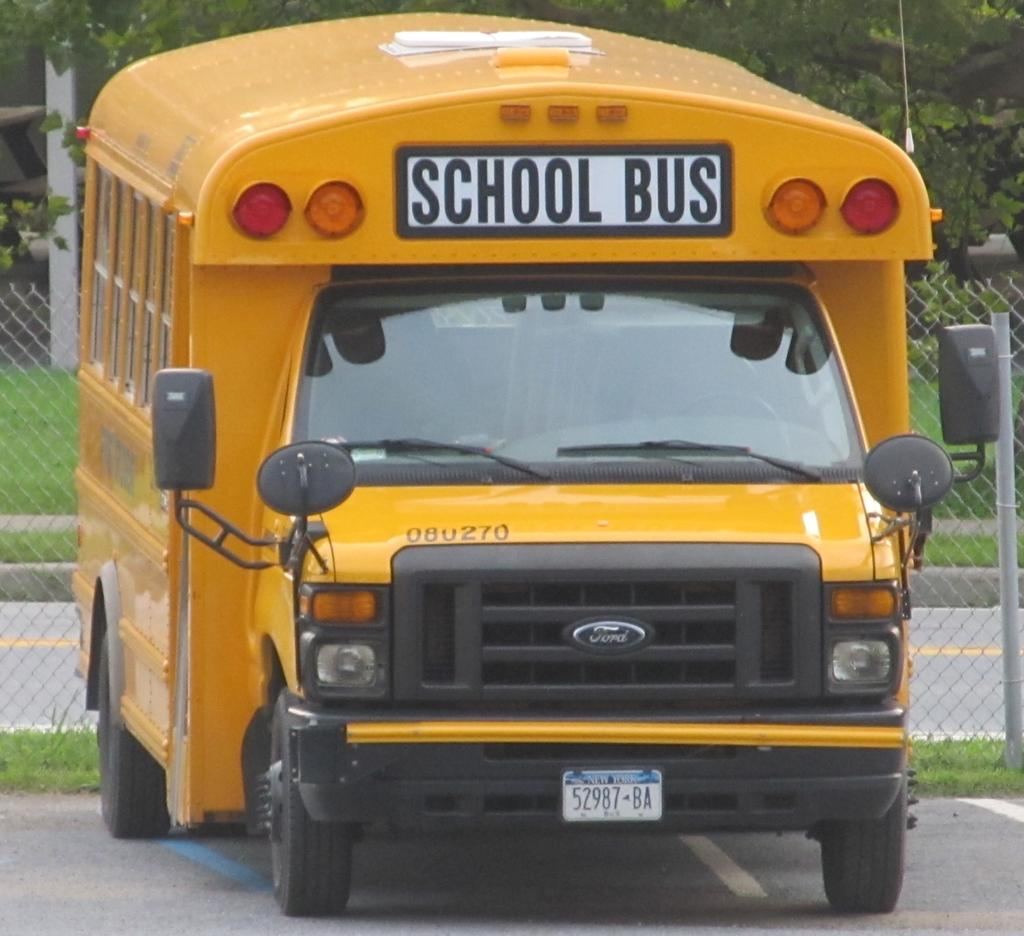<image>
Create a compact narrative representing the image presented. A yellow Ford bus titled SCHOOL BUS with the number 080270 